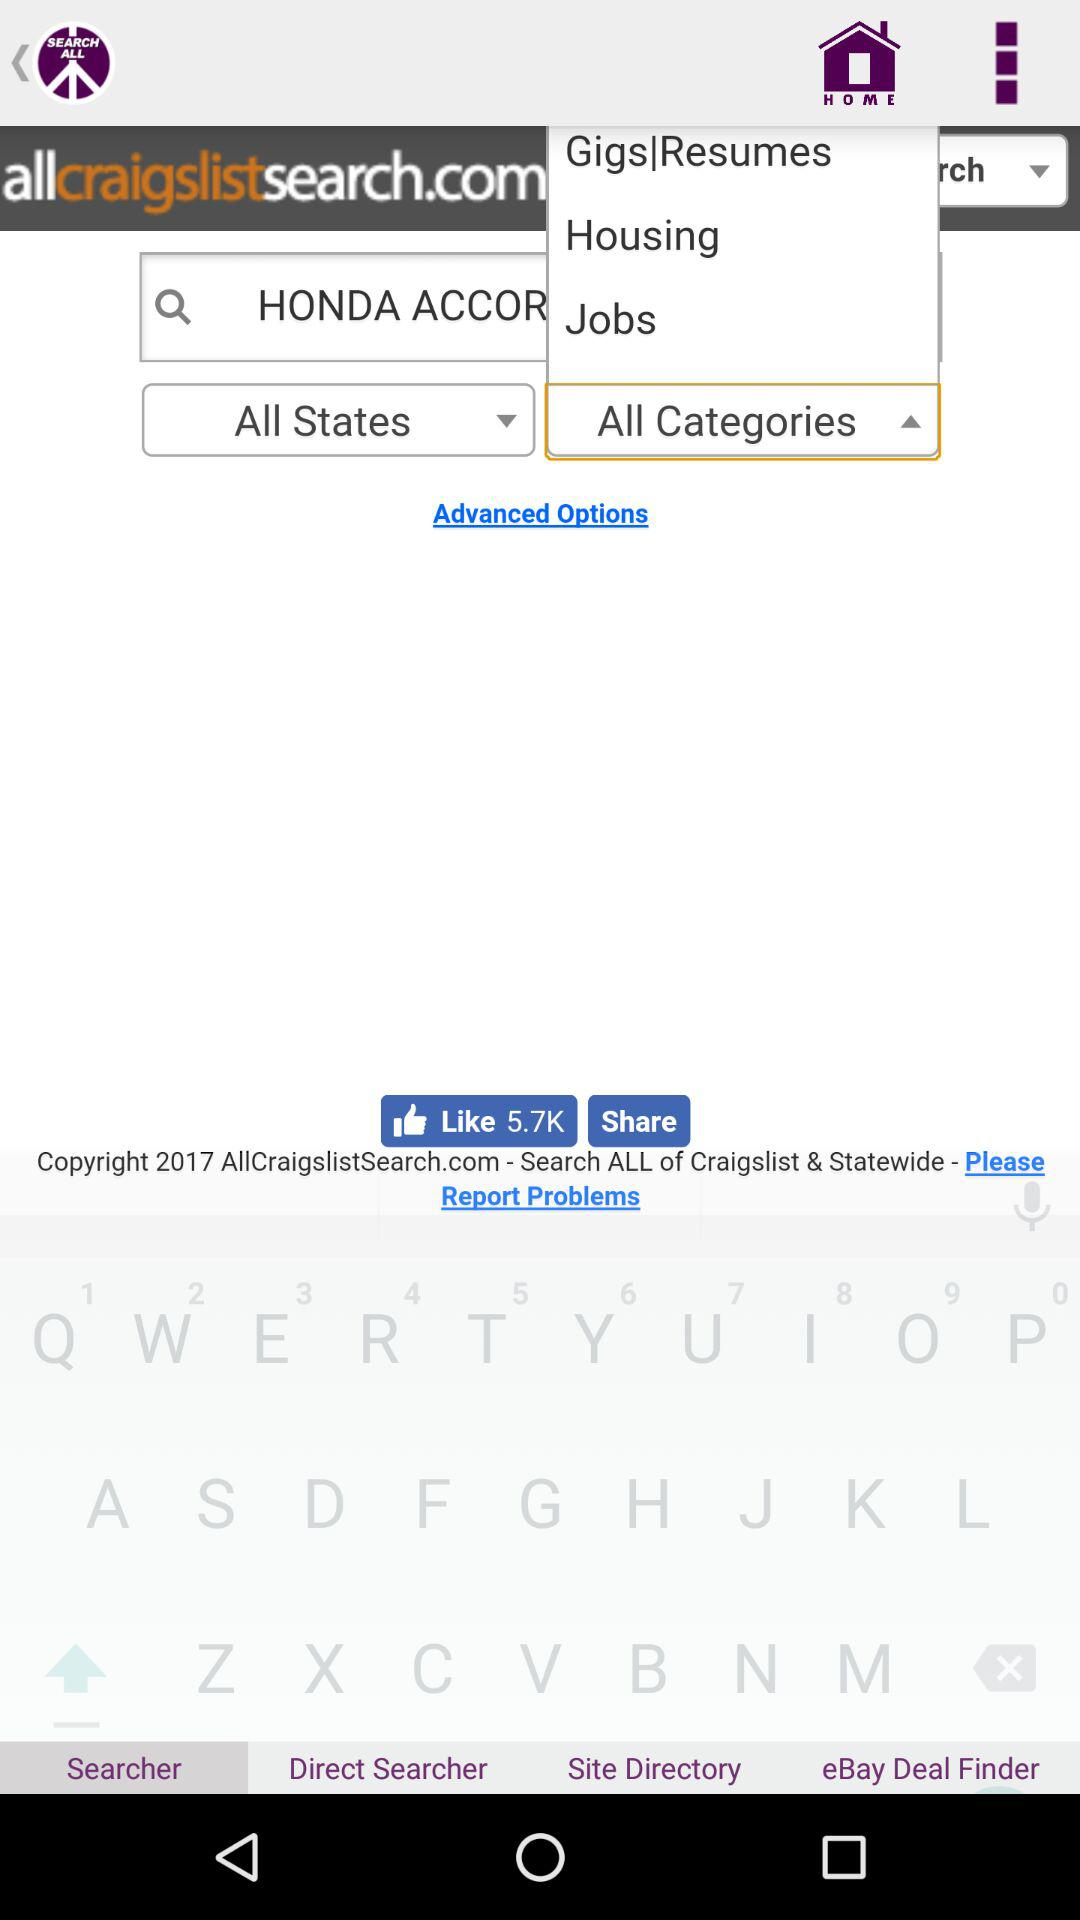Which tab is selected? The selected tab is "Searcher". 